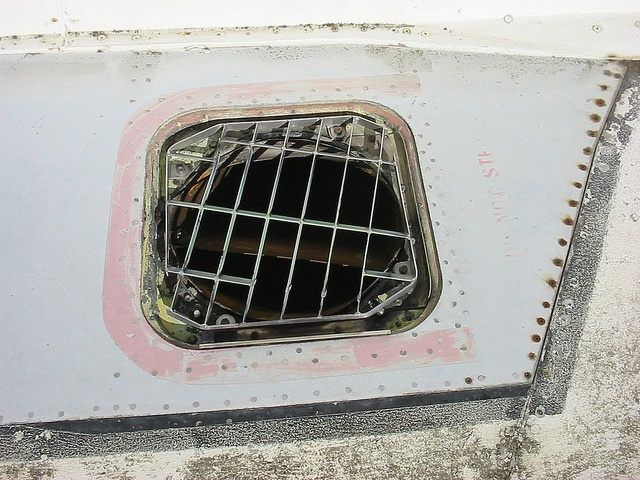Describe the objects in this image and their specific colors. I can see various objects in this image with different colors. 